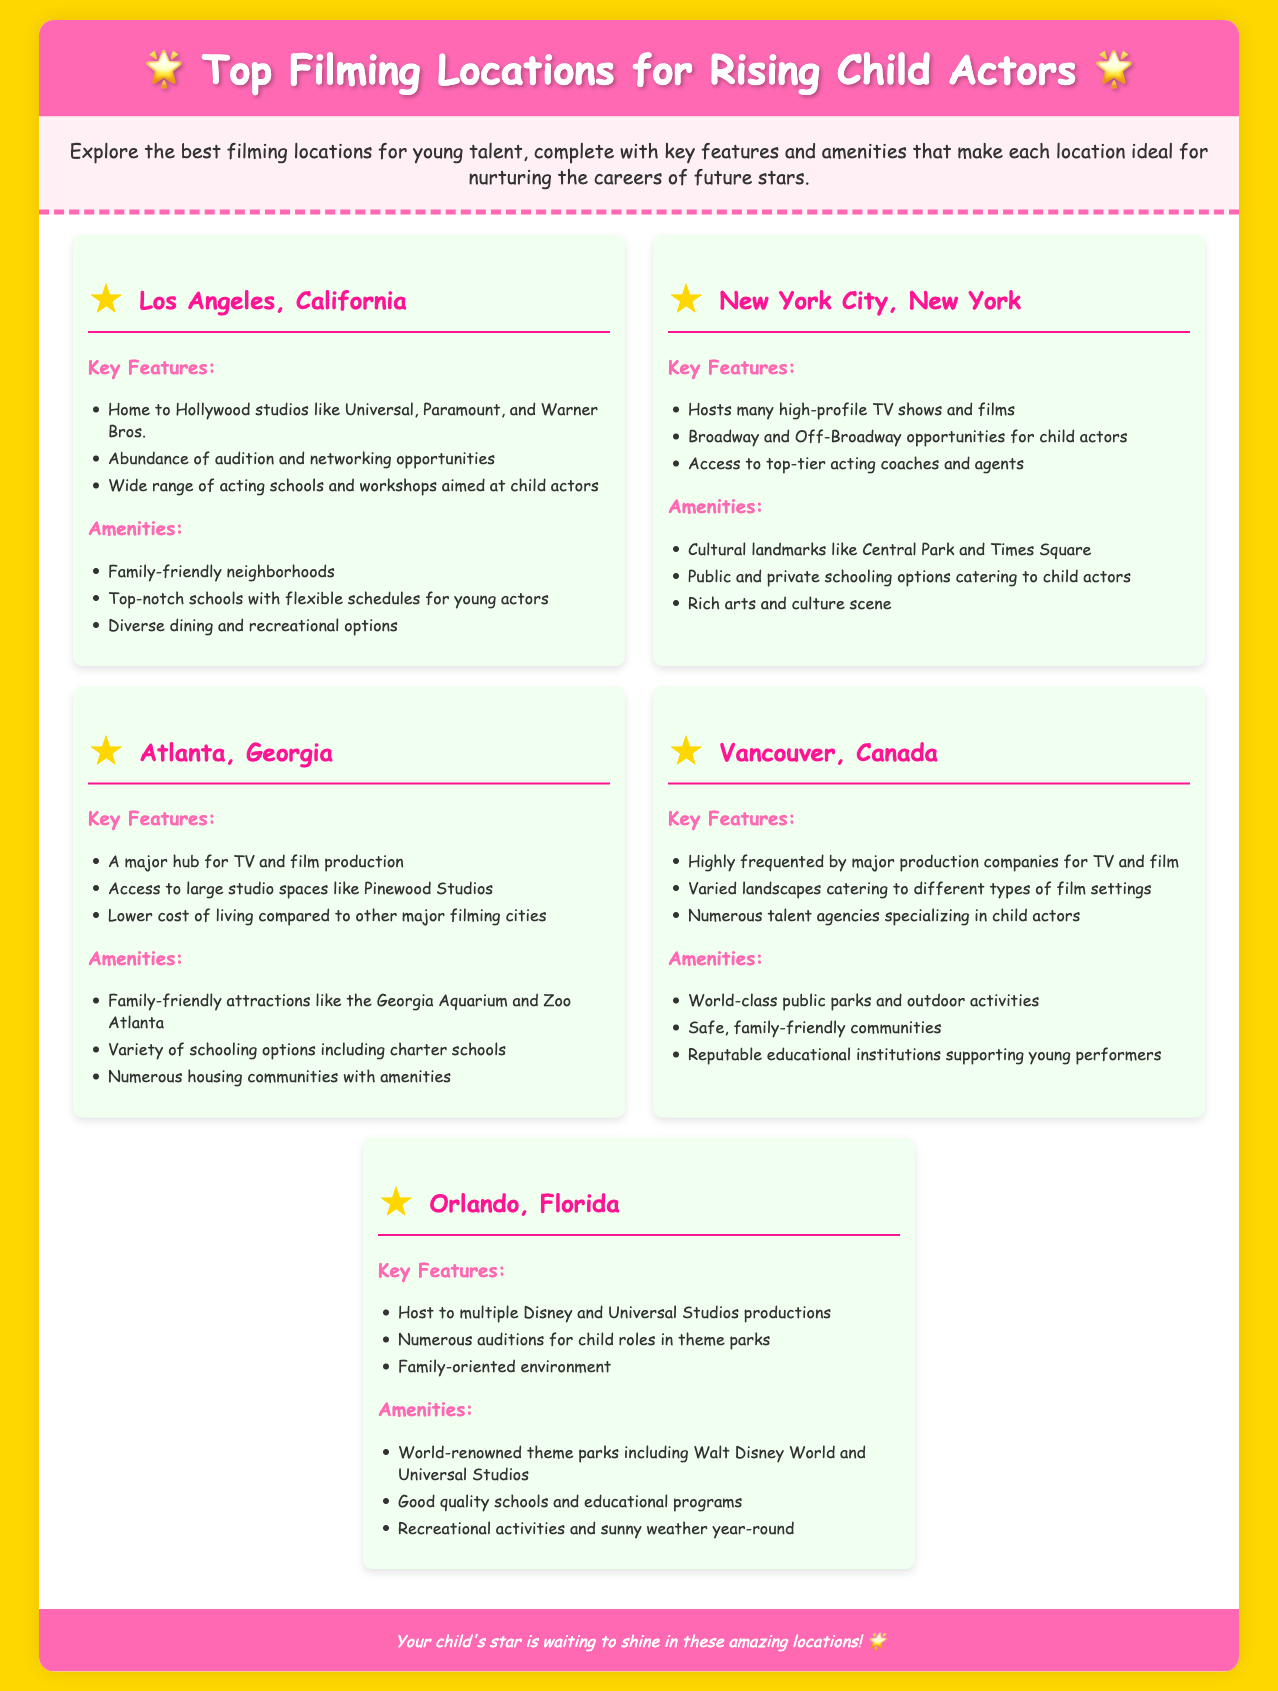What are the top filming locations for rising child actors? The top filming locations listed are Los Angeles, New York City, Atlanta, Vancouver, and Orlando.
Answer: Los Angeles, New York City, Atlanta, Vancouver, Orlando Which filming location is known for Broadway opportunities? The location with Broadway opportunities is New York City.
Answer: New York City What unique feature does Atlanta offer compared to other filming locations? Atlanta offers a lower cost of living compared to other major filming cities.
Answer: Lower cost of living What type of environment does Orlando provide for families? Orlando provides a family-oriented environment.
Answer: Family-oriented environment Which location is highlighted for having diverse dining options? The location known for diverse dining options is Los Angeles.
Answer: Los Angeles How many filming locations are mentioned in the document? There are five locations mentioned in the document.
Answer: Five What feature do all locations have in common? Each location has amenities that cater to young actors.
Answer: Amenities for young actors Which filming location is associated with world-renowned theme parks? The filming location associated with world-renowned theme parks is Orlando.
Answer: Orlando What is a key amenity of Vancouver? A key amenity of Vancouver is safe, family-friendly communities.
Answer: Safe, family-friendly communities 